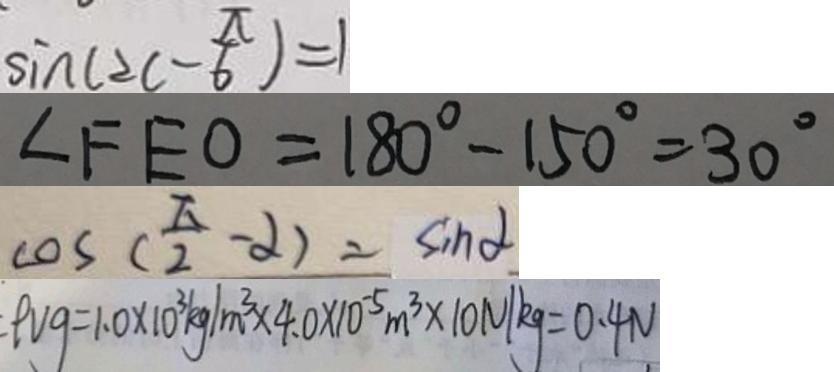Convert formula to latex. <formula><loc_0><loc_0><loc_500><loc_500>\sin ( 2 c - \frac { \pi } { 6 } ) = 1 
 \angle F E O = 1 8 0 ^ { \circ } - 1 5 0 ^ { \circ } = 3 0 ^ { \circ } 
 \cos ( \frac { \pi } { 2 } - \alpha ) = \sin \alpha 
 \rho v g = 1 . 0 \times 1 0 ^ { 3 } k g / m ^ { 3 } \times 4 . 0 \times 1 0 ^ { - 5 } m ^ { 3 } \times 1 0 N / k g = 0 . 4 N</formula> 